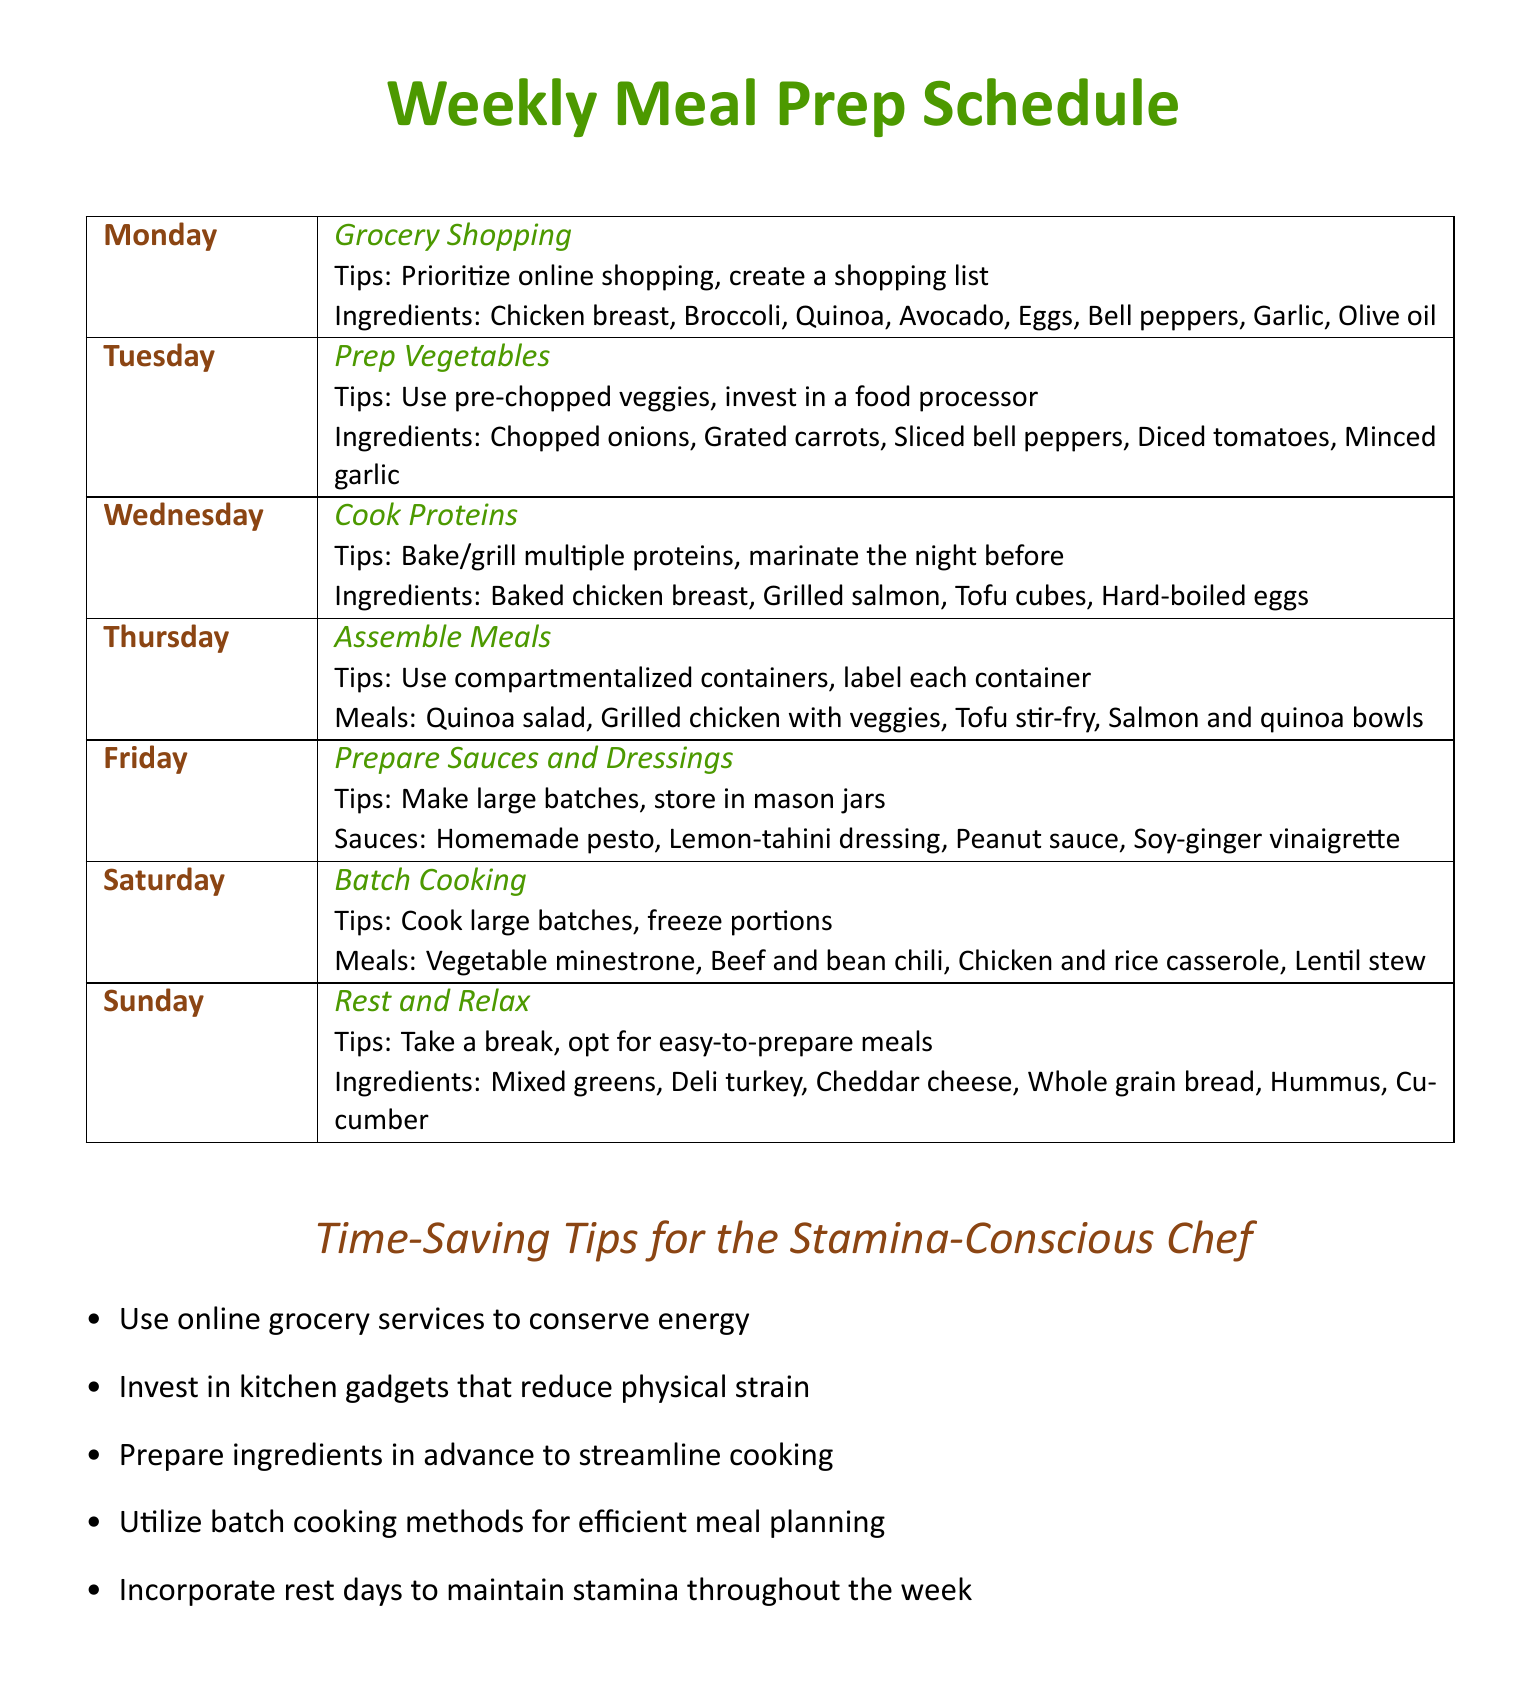What day is designated for grocery shopping? The document states that grocery shopping is scheduled for Monday.
Answer: Monday Which ingredient is listed for Tuesday's meal prep? Chopped onions are included in the ingredient list for Tuesday's vegetable prep.
Answer: Chopped onions What is a suggested tip for assembling meals? The document mentions using compartmentalized containers as a tip for meal assembly.
Answer: Compartmentalized containers How many different sauces are suggested for preparation on Friday? There are four different sauces listed for preparation on Friday.
Answer: Four What type of dish is included in Saturday's batch cooking? Vegetable minestrone is one of the dishes included in Saturday's batch cooking.
Answer: Vegetable minestrone Which meal does Sunday recommend for a rest day? The document suggests opting for easy-to-prepare meals on Sunday.
Answer: Easy-to-prepare meals What is one of the time-saving tips for the stamina-conscious chef? One tip is to use online grocery services to conserve energy.
Answer: Online grocery services Which day is focused on cooking proteins? The document assigns Wednesday to the task of cooking proteins.
Answer: Wednesday 